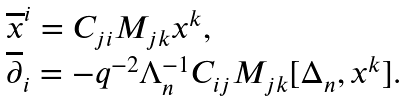Convert formula to latex. <formula><loc_0><loc_0><loc_500><loc_500>\begin{array} { l } { { { \overline { x } ^ { i } } = C _ { j i } M _ { j k } x ^ { k } , } } \\ { { { \overline { \partial } _ { i } } = - q ^ { - 2 } \Lambda _ { n } ^ { - 1 } C _ { i j } M _ { j k } [ \Delta _ { n } , x ^ { k } ] . } } \end{array}</formula> 